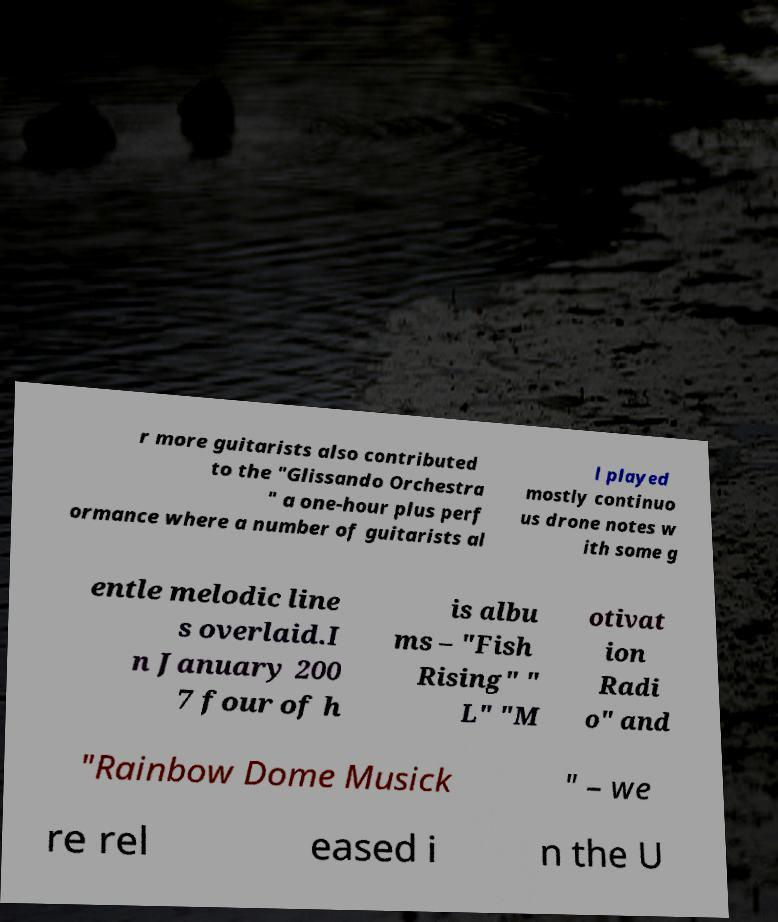I need the written content from this picture converted into text. Can you do that? r more guitarists also contributed to the "Glissando Orchestra " a one-hour plus perf ormance where a number of guitarists al l played mostly continuo us drone notes w ith some g entle melodic line s overlaid.I n January 200 7 four of h is albu ms – "Fish Rising" " L" "M otivat ion Radi o" and "Rainbow Dome Musick " – we re rel eased i n the U 